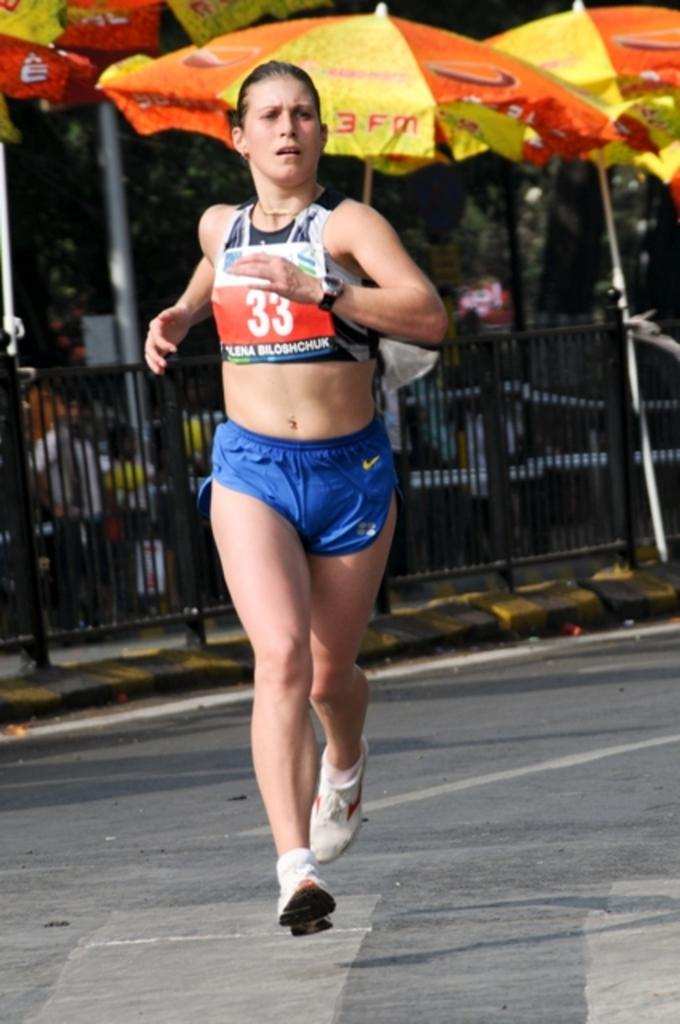<image>
Share a concise interpretation of the image provided. A women running a marathon with blue shorts and the number 33 on her sports bra. 